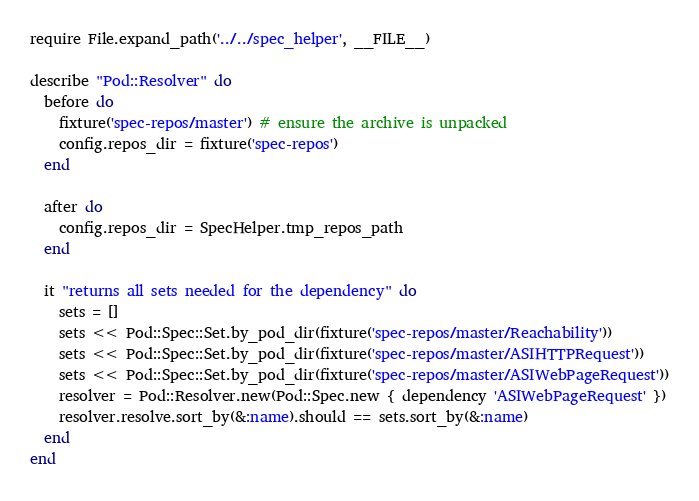<code> <loc_0><loc_0><loc_500><loc_500><_Ruby_>require File.expand_path('../../spec_helper', __FILE__)

describe "Pod::Resolver" do
  before do
    fixture('spec-repos/master') # ensure the archive is unpacked
    config.repos_dir = fixture('spec-repos')
  end

  after do
    config.repos_dir = SpecHelper.tmp_repos_path
  end

  it "returns all sets needed for the dependency" do
    sets = []
    sets << Pod::Spec::Set.by_pod_dir(fixture('spec-repos/master/Reachability'))
    sets << Pod::Spec::Set.by_pod_dir(fixture('spec-repos/master/ASIHTTPRequest'))
    sets << Pod::Spec::Set.by_pod_dir(fixture('spec-repos/master/ASIWebPageRequest'))
    resolver = Pod::Resolver.new(Pod::Spec.new { dependency 'ASIWebPageRequest' })
    resolver.resolve.sort_by(&:name).should == sets.sort_by(&:name)
  end
end

</code> 